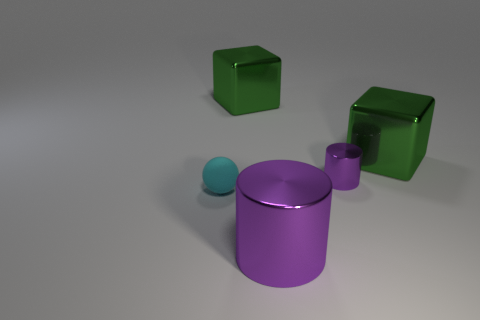There is a cyan matte thing; what number of big green metallic things are in front of it?
Your response must be concise. 0. Do the tiny sphere and the green block left of the big purple cylinder have the same material?
Your answer should be very brief. No. The other purple cylinder that is made of the same material as the big cylinder is what size?
Offer a very short reply. Small. Is the number of rubber spheres to the right of the tiny rubber ball greater than the number of balls that are right of the large purple cylinder?
Your answer should be very brief. No. Is there another small object of the same shape as the small rubber object?
Provide a succinct answer. No. There is a purple cylinder that is in front of the rubber ball; does it have the same size as the tiny sphere?
Make the answer very short. No. Is there a small cyan ball?
Offer a terse response. Yes. How many objects are either small objects behind the tiny rubber ball or big purple metallic cylinders?
Keep it short and to the point. 2. Does the rubber sphere have the same color as the large thing left of the big purple cylinder?
Ensure brevity in your answer.  No. Are there any blocks of the same size as the cyan matte sphere?
Offer a terse response. No. 